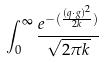<formula> <loc_0><loc_0><loc_500><loc_500>\int _ { 0 } ^ { \infty } \frac { e ^ { - ( \frac { ( q \cdot g ) ^ { 2 } } { 2 k } ) } } { \sqrt { 2 \pi k } }</formula> 